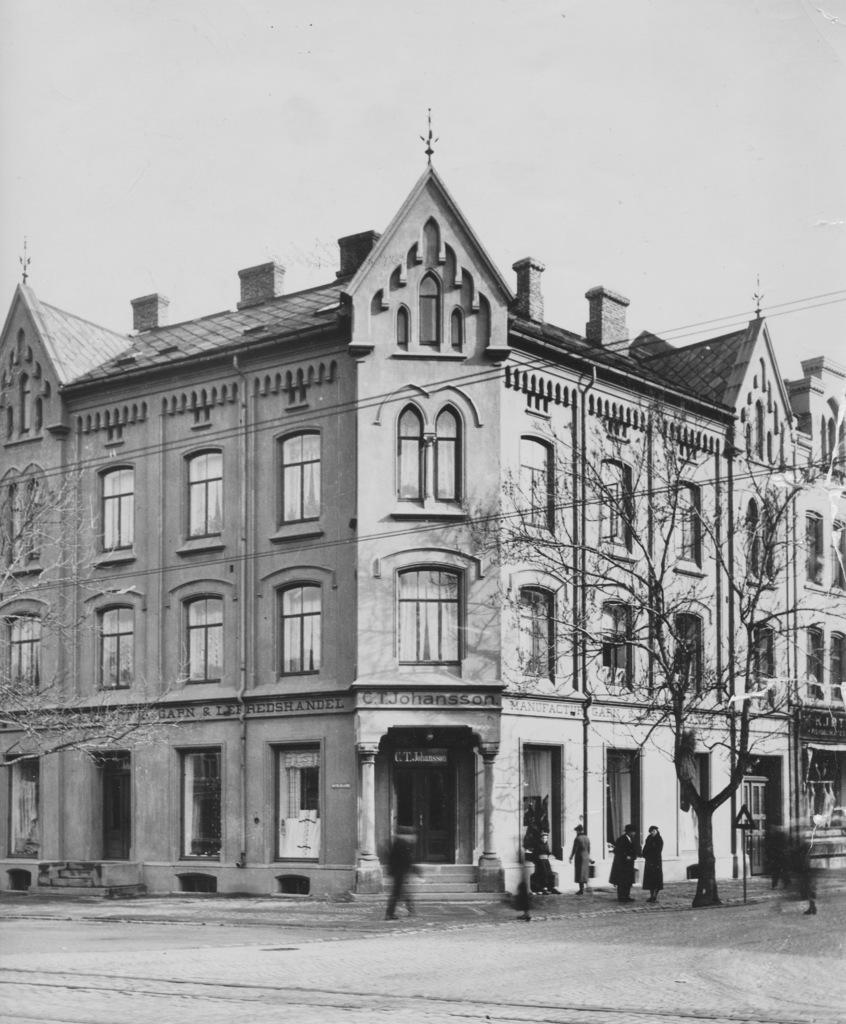What type of structure is present in the image? There is a building in the image. Can you describe the people in the image? There are people in the image. What other objects or elements can be seen in the image? There is a tree, a signboard, and the sky is visible in the image. What are the characteristics of the building? The building has windows and doors. How many cars are parked in front of the building in the image? There are no cars present in the image. What type of rail is used to attract the attention of the people in the image? There is no rail or any specific attention-grabbing element mentioned in the image. 